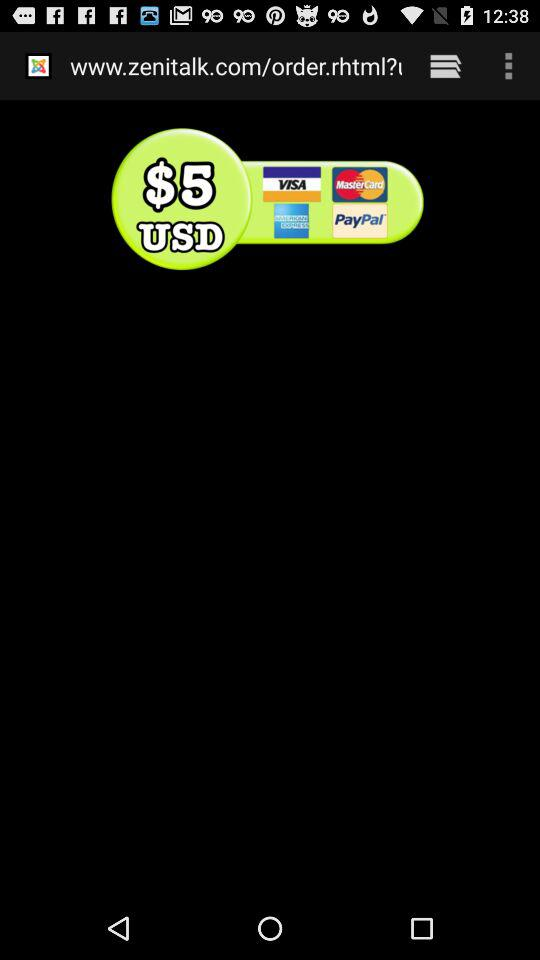How many more credit card logos are there than text inputs?
Answer the question using a single word or phrase. 4 